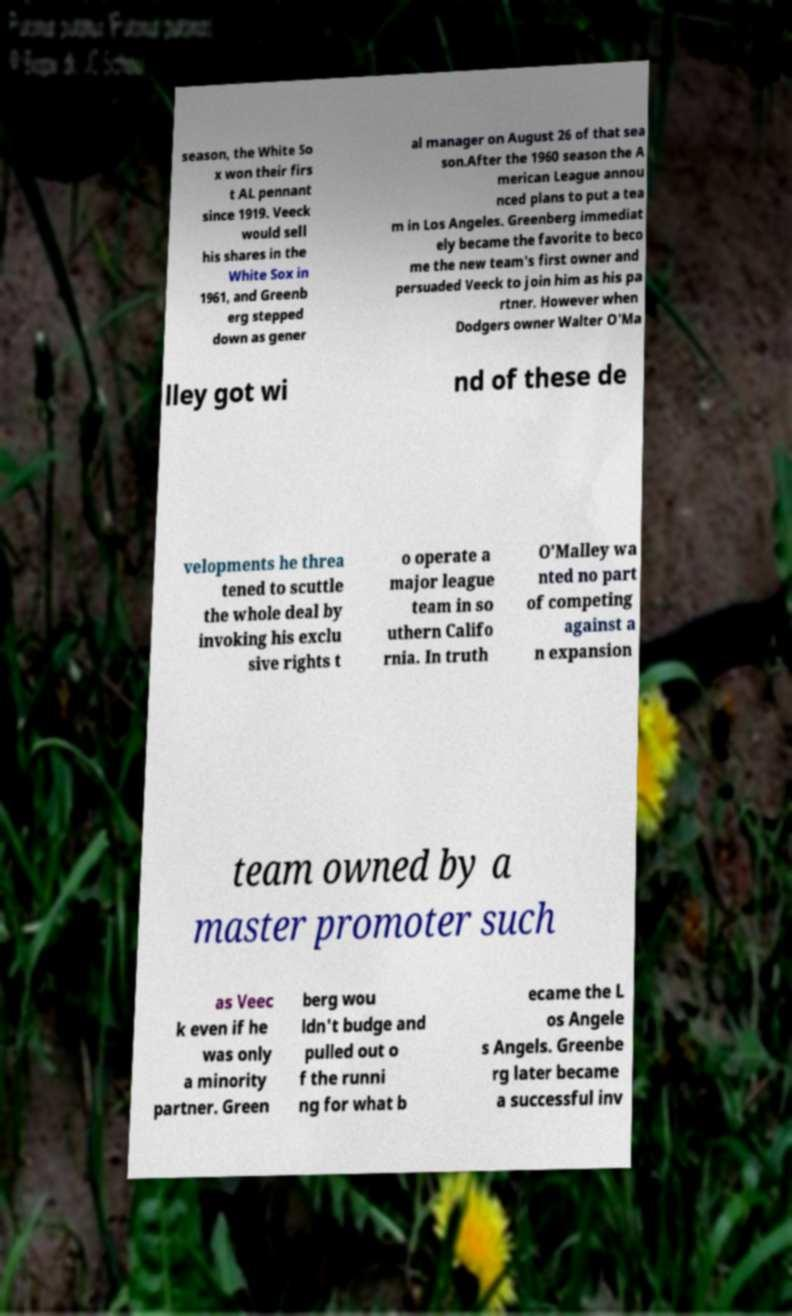There's text embedded in this image that I need extracted. Can you transcribe it verbatim? season, the White So x won their firs t AL pennant since 1919. Veeck would sell his shares in the White Sox in 1961, and Greenb erg stepped down as gener al manager on August 26 of that sea son.After the 1960 season the A merican League annou nced plans to put a tea m in Los Angeles. Greenberg immediat ely became the favorite to beco me the new team's first owner and persuaded Veeck to join him as his pa rtner. However when Dodgers owner Walter O'Ma lley got wi nd of these de velopments he threa tened to scuttle the whole deal by invoking his exclu sive rights t o operate a major league team in so uthern Califo rnia. In truth O'Malley wa nted no part of competing against a n expansion team owned by a master promoter such as Veec k even if he was only a minority partner. Green berg wou ldn't budge and pulled out o f the runni ng for what b ecame the L os Angele s Angels. Greenbe rg later became a successful inv 